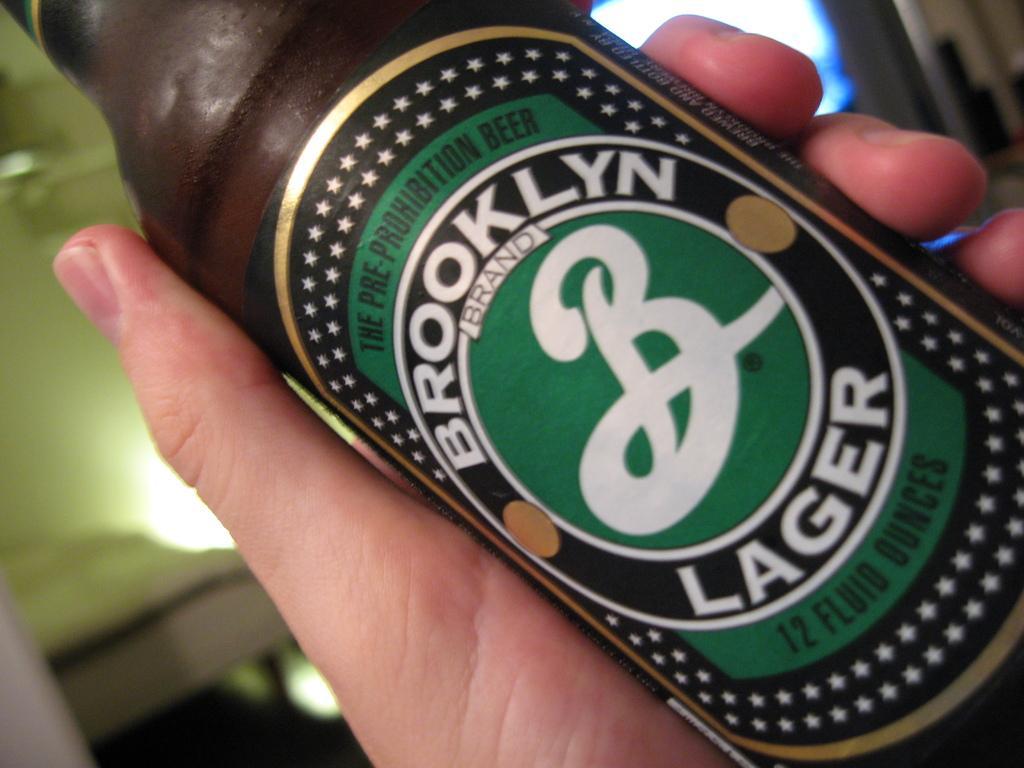Could you give a brief overview of what you see in this image? In the picture we can see a person hand holding a wine bottle and label on it with a name Brooklyn lager. 